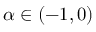Convert formula to latex. <formula><loc_0><loc_0><loc_500><loc_500>\alpha \in ( - 1 , 0 )</formula> 